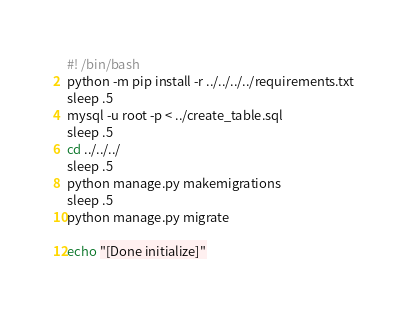Convert code to text. <code><loc_0><loc_0><loc_500><loc_500><_Bash_>#! /bin/bash
python -m pip install -r ../../../../requirements.txt
sleep .5
mysql -u root -p < ../create_table.sql
sleep .5
cd ../../../
sleep .5
python manage.py makemigrations
sleep .5
python manage.py migrate

echo "[Done initialize]"</code> 